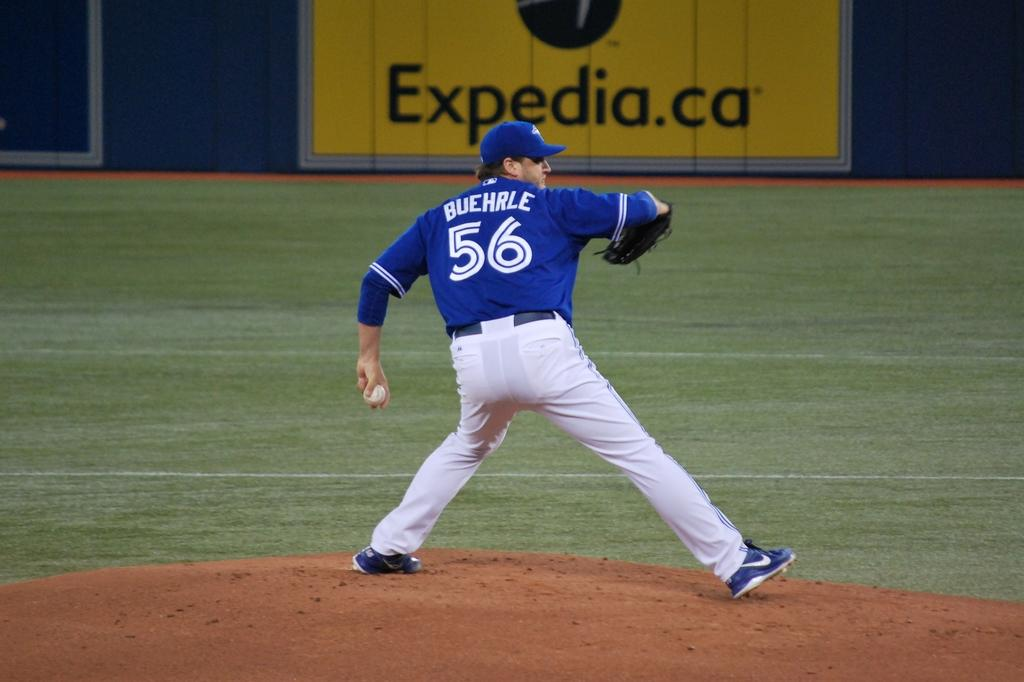<image>
Provide a brief description of the given image. A pitcher with the blue jersey number 56 stands on a mound ready to throw 